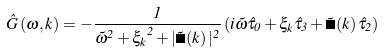<formula> <loc_0><loc_0><loc_500><loc_500>\hat { G } \left ( \omega , { k } \right ) = - \frac { 1 } { \tilde { \omega } ^ { 2 } + { \xi _ { k } } ^ { 2 } + | \tilde { \Delta } \left ( { k } \right ) | ^ { 2 } } \left ( i \tilde { \omega } \hat { \tau } _ { 0 } + \xi _ { k } \hat { \tau } _ { 3 } + \tilde { \Delta } \left ( { k } \right ) \hat { \tau } _ { 2 } \right )</formula> 